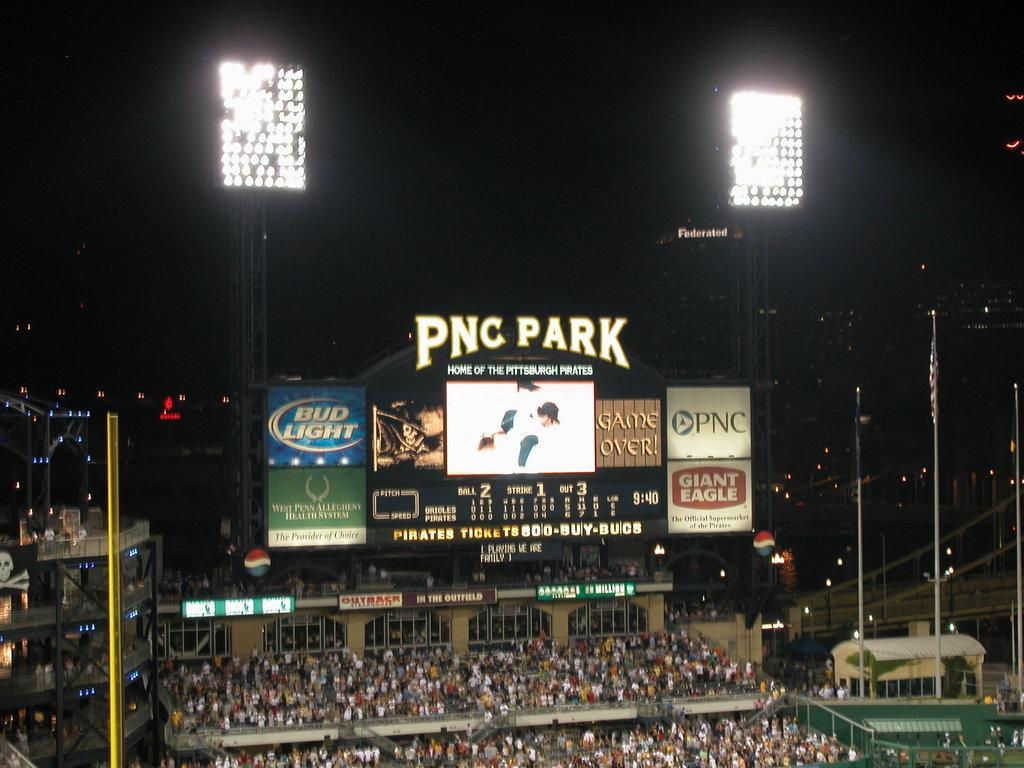Provide a one-sentence caption for the provided image. Night ball game being played PNC Park with the stands full. 